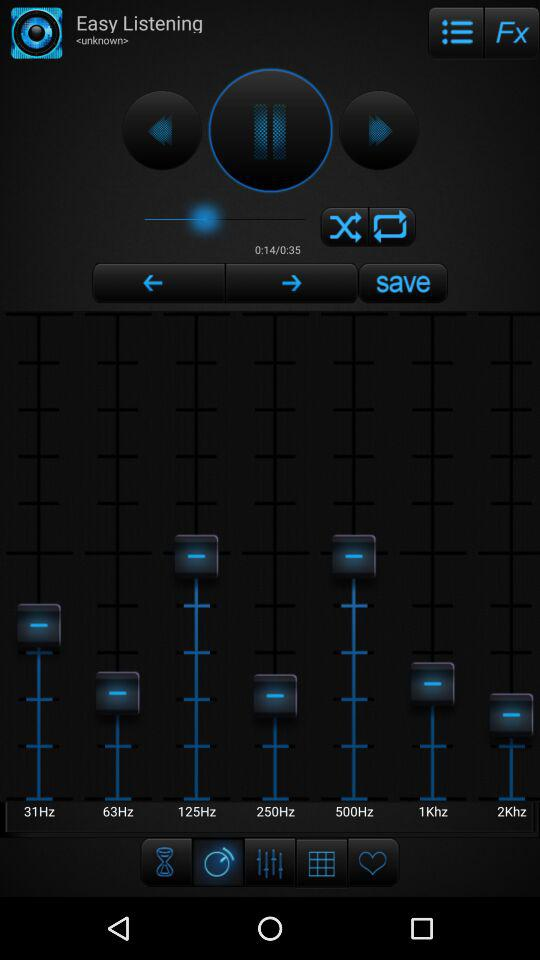Who is the artist of the playing audio? The artist is unknown. 